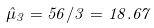Convert formula to latex. <formula><loc_0><loc_0><loc_500><loc_500>\hat { \mu } _ { 3 } = 5 6 / 3 = 1 8 . 6 7</formula> 